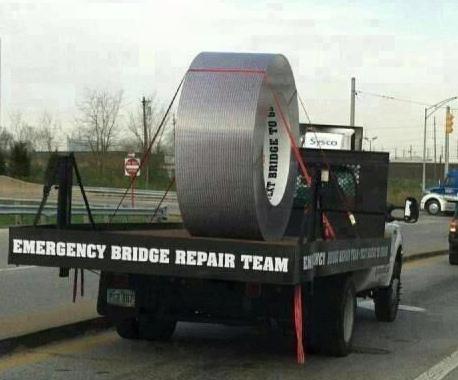Is this roll a prop?
Quick response, please. Yes. Is there duct tape in the image?
Be succinct. Yes. What kind of structure does this vehicle service?
Short answer required. Bridge. 